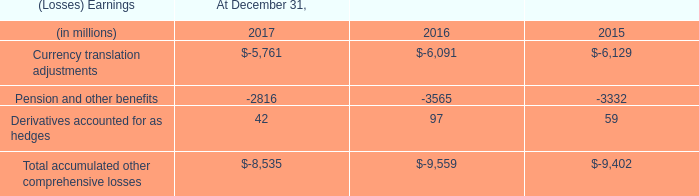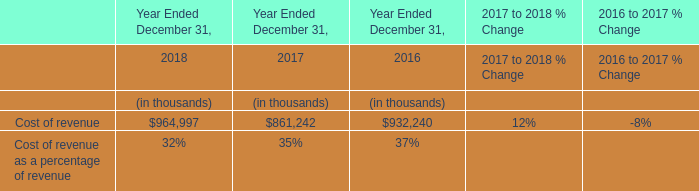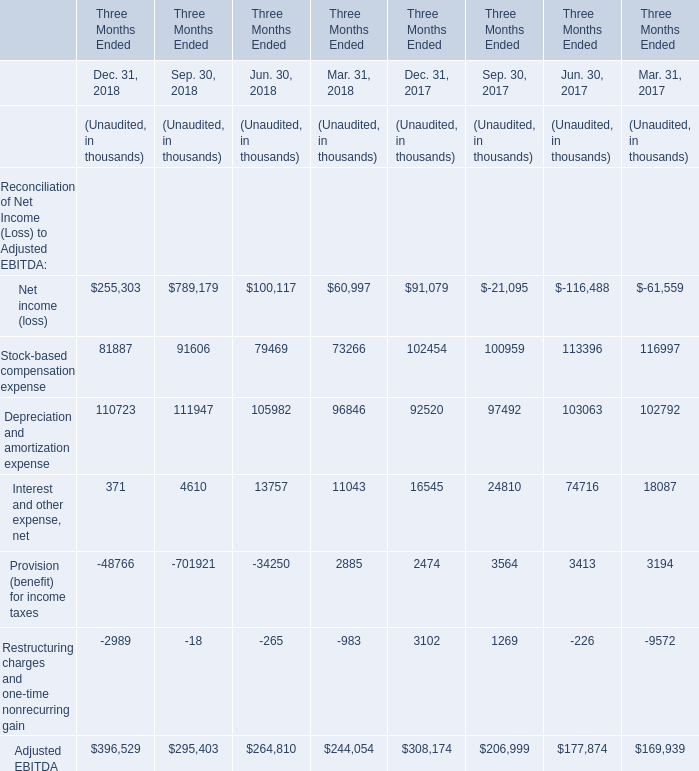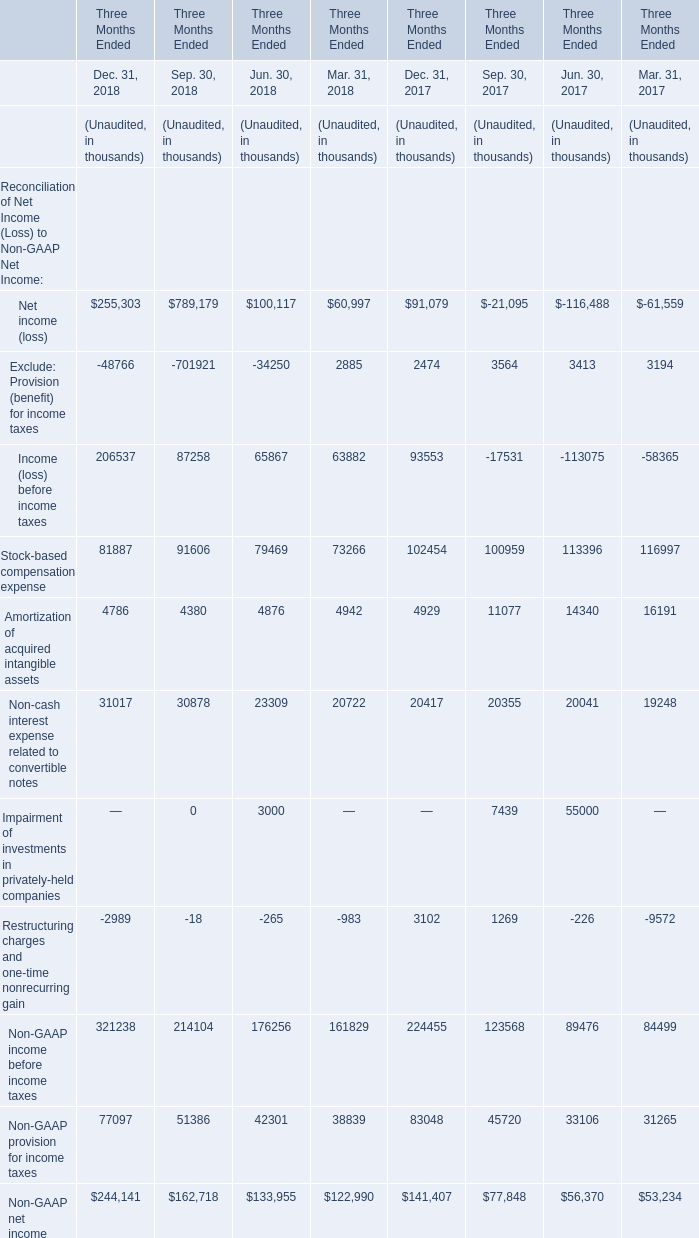What's the greatest value of Reconciliation of Net Income (Loss) to Non-GAAP Net Income in Dec.31,2018? 
Answer: Non-GAAP income before income taxes. 